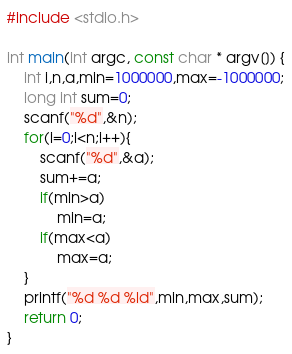<code> <loc_0><loc_0><loc_500><loc_500><_C_>#include <stdio.h>

int main(int argc, const char * argv[]) {
    int i,n,a,min=1000000,max=-1000000;
    long int sum=0;
    scanf("%d",&n);
    for(i=0;i<n;i++){
        scanf("%d",&a);
        sum+=a;
        if(min>a)
            min=a;
        if(max<a)
            max=a;
    }
    printf("%d %d %ld",min,max,sum);
    return 0;
}</code> 